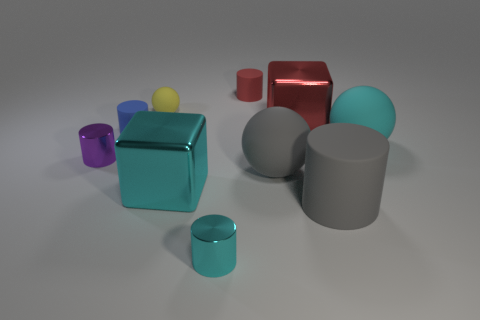Subtract 1 cylinders. How many cylinders are left? 4 Subtract all blue cylinders. How many cylinders are left? 4 Subtract all large rubber cylinders. How many cylinders are left? 4 Subtract all yellow cylinders. Subtract all purple cubes. How many cylinders are left? 5 Subtract all cubes. How many objects are left? 8 Add 6 cyan blocks. How many cyan blocks exist? 7 Subtract 0 brown blocks. How many objects are left? 10 Subtract all large cyan spheres. Subtract all big red metal objects. How many objects are left? 8 Add 5 blocks. How many blocks are left? 7 